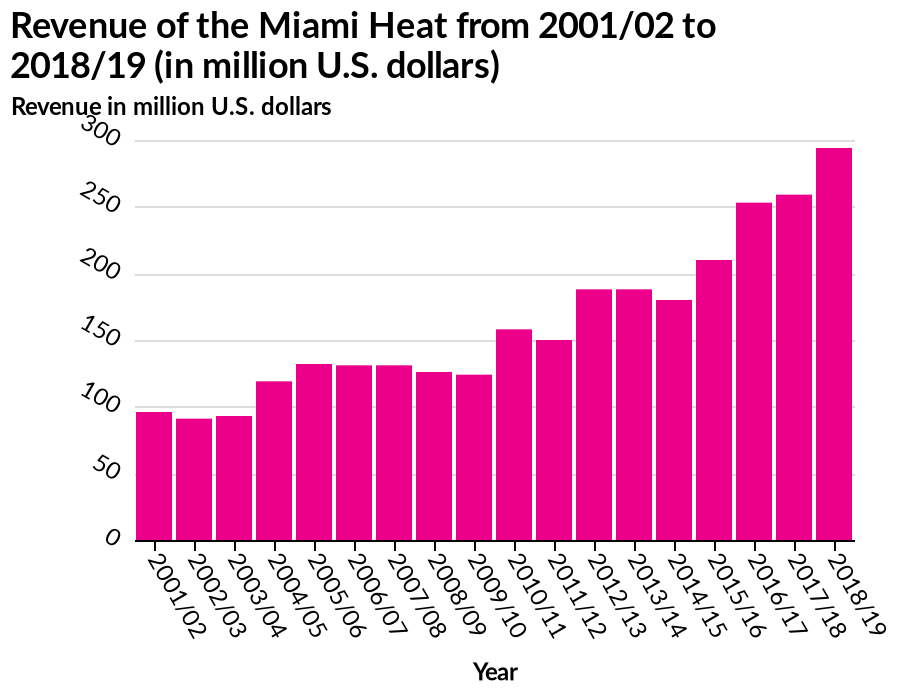<image>
In which year did the Miami Heat have the highest revenue?  The given information does not specify the year with the highest revenue for the Miami Heat. Offer a thorough analysis of the image. The revenue that the Miami Heat has generated each season has tripled from just under 100 million US dollars in the 2001/02 season to just under 300 million US dollars in the 2018/19 season. Between the 2014/15 season until the 2018/19 season the revenue generated by the Miami Heat has increased every season. Between the 2005/06 season and the 2009/10 season the revenue generated by the Miami Heat decreased slightly each season with the exception of the 2006/07 and the 2007/08 seasons where it remained the same. 